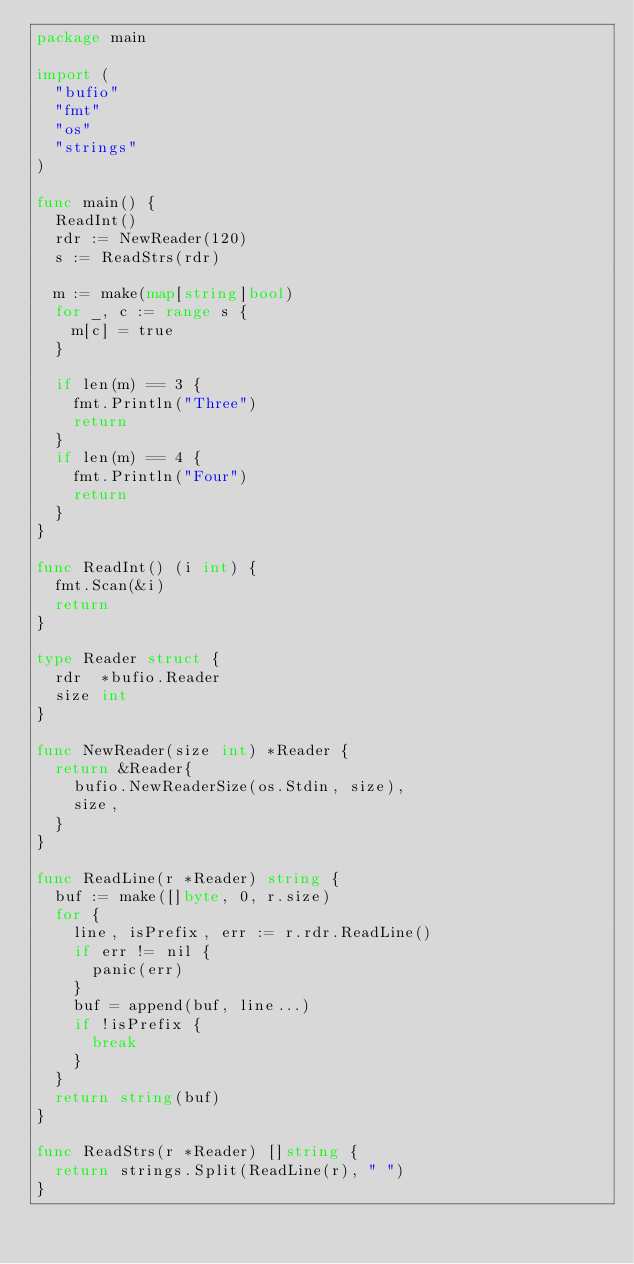Convert code to text. <code><loc_0><loc_0><loc_500><loc_500><_Go_>package main

import (
	"bufio"
	"fmt"
	"os"
	"strings"
)

func main() {
	ReadInt()
	rdr := NewReader(120)
	s := ReadStrs(rdr)

	m := make(map[string]bool)
	for _, c := range s {
		m[c] = true
	}

	if len(m) == 3 {
		fmt.Println("Three")
		return
	}
	if len(m) == 4 {
		fmt.Println("Four")
		return
	}
}

func ReadInt() (i int) {
	fmt.Scan(&i)
	return
}

type Reader struct {
	rdr  *bufio.Reader
	size int
}

func NewReader(size int) *Reader {
	return &Reader{
		bufio.NewReaderSize(os.Stdin, size),
		size,
	}
}

func ReadLine(r *Reader) string {
	buf := make([]byte, 0, r.size)
	for {
		line, isPrefix, err := r.rdr.ReadLine()
		if err != nil {
			panic(err)
		}
		buf = append(buf, line...)
		if !isPrefix {
			break
		}
	}
	return string(buf)
}

func ReadStrs(r *Reader) []string {
	return strings.Split(ReadLine(r), " ")
}
</code> 